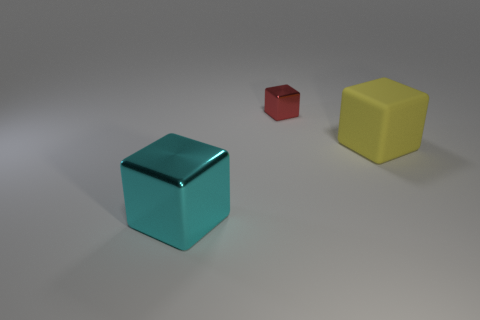Subtract all large cubes. How many cubes are left? 1 Add 1 small blocks. How many objects exist? 4 Add 1 large cyan metallic things. How many large cyan metallic things exist? 2 Subtract 0 green spheres. How many objects are left? 3 Subtract 3 blocks. How many blocks are left? 0 Subtract all green blocks. Subtract all yellow cylinders. How many blocks are left? 3 Subtract all brown balls. How many gray blocks are left? 0 Subtract all yellow cubes. Subtract all big yellow matte cubes. How many objects are left? 1 Add 1 cyan cubes. How many cyan cubes are left? 2 